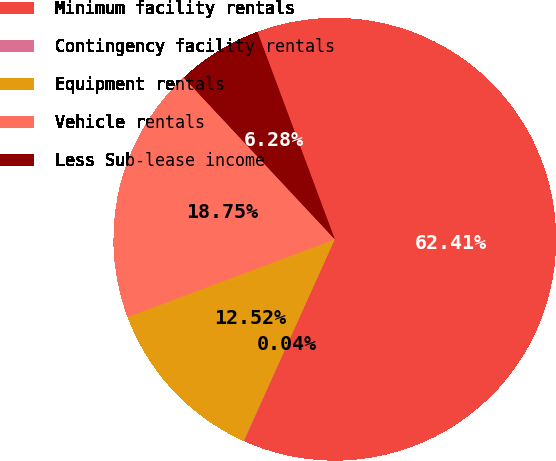Convert chart. <chart><loc_0><loc_0><loc_500><loc_500><pie_chart><fcel>Minimum facility rentals<fcel>Contingency facility rentals<fcel>Equipment rentals<fcel>Vehicle rentals<fcel>Less Sub-lease income<nl><fcel>62.41%<fcel>0.04%<fcel>12.52%<fcel>18.75%<fcel>6.28%<nl></chart> 